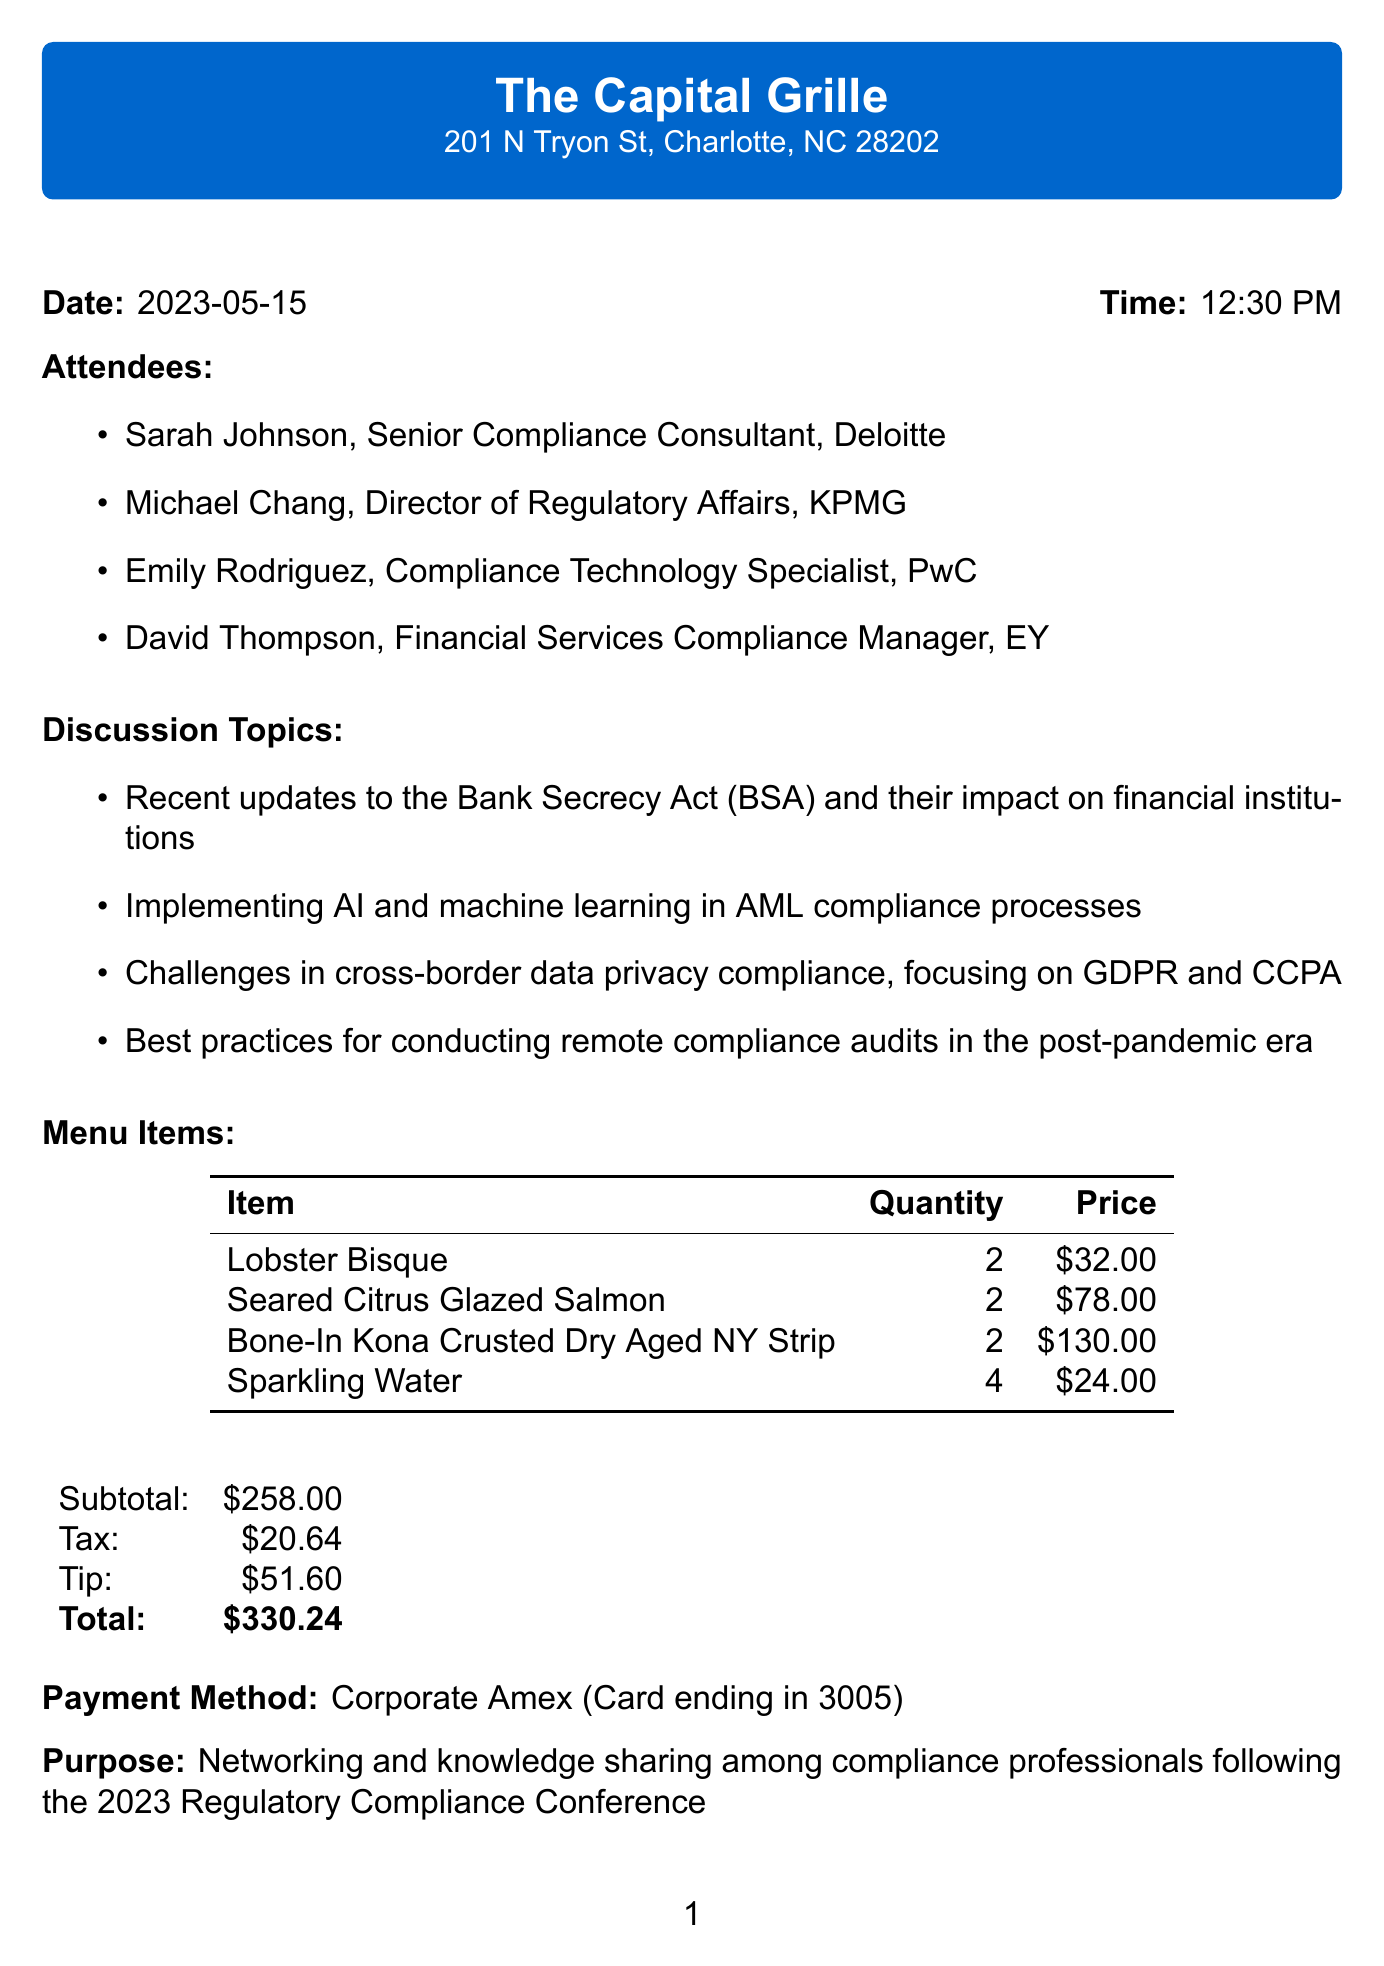What is the restaurant name? The restaurant name is found in the header of the document, which specifies where the meal took place.
Answer: The Capital Grille What was the date of the meeting? The date is mentioned clearly in the document, indicating when the business lunch occurred.
Answer: 2023-05-15 Who is the Compliance Technology Specialist? The title and company of each attendee are listed, making it easy to identify them.
Answer: Emily Rodriguez What is the total cost of the lunch? The total cost includes all expenses listed in the document, combining the subtotal, tax, and tip.
Answer: $330.24 Which discussion topic focuses on technology? This question requires reasoning by looking at the discussion topics and identifying which one relates to technology.
Answer: Implementing AI and machine learning in AML compliance processes How many Lobster Bisque were ordered? The quantity of each menu item ordered is specified directly under each item.
Answer: 2 What payment method was used? The payment method is specified towards the end of the document, highlighting how the bill was settled.
Answer: Corporate Amex What is the purpose of the meeting? The purpose is directly stated in the document, detailing the reason for the gathering of compliance professionals.
Answer: Networking and knowledge sharing among compliance professionals following the 2023 Regulatory Compliance Conference How many attendees were there? The number of attendees can be counted based on the list provided in the document.
Answer: 4 